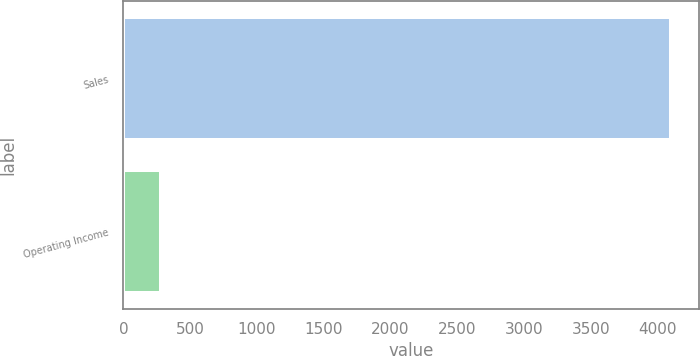Convert chart to OTSL. <chart><loc_0><loc_0><loc_500><loc_500><bar_chart><fcel>Sales<fcel>Operating Income<nl><fcel>4104<fcel>280<nl></chart> 